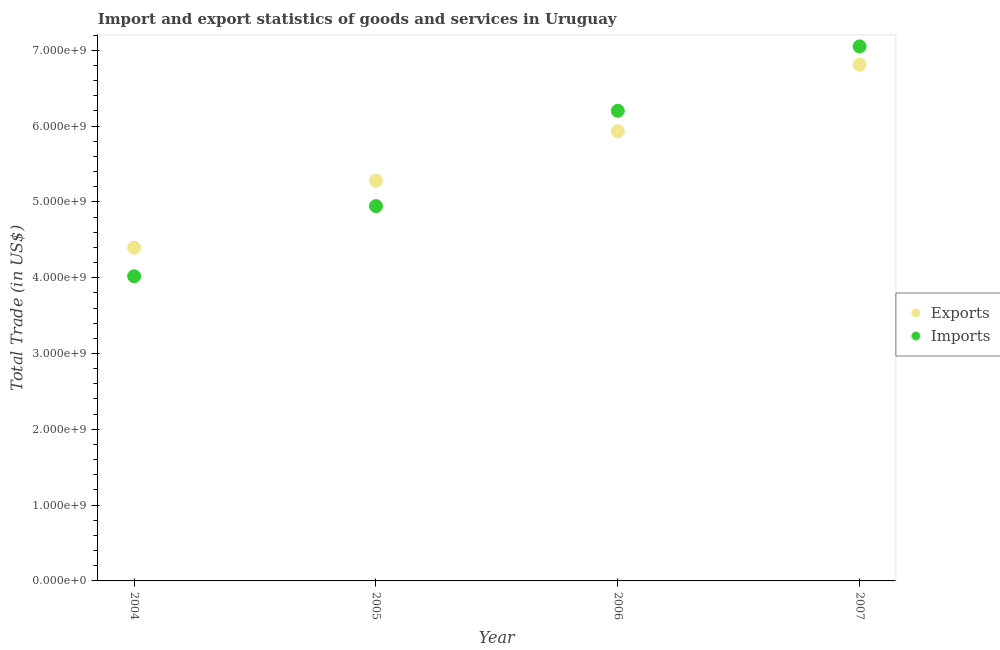How many different coloured dotlines are there?
Provide a succinct answer. 2. Is the number of dotlines equal to the number of legend labels?
Make the answer very short. Yes. What is the imports of goods and services in 2005?
Keep it short and to the point. 4.94e+09. Across all years, what is the maximum export of goods and services?
Give a very brief answer. 6.81e+09. Across all years, what is the minimum imports of goods and services?
Your answer should be compact. 4.02e+09. In which year was the imports of goods and services maximum?
Your answer should be compact. 2007. In which year was the imports of goods and services minimum?
Your answer should be very brief. 2004. What is the total imports of goods and services in the graph?
Give a very brief answer. 2.22e+1. What is the difference between the export of goods and services in 2004 and that in 2007?
Offer a terse response. -2.42e+09. What is the difference between the imports of goods and services in 2007 and the export of goods and services in 2005?
Give a very brief answer. 1.77e+09. What is the average imports of goods and services per year?
Provide a succinct answer. 5.55e+09. In the year 2005, what is the difference between the imports of goods and services and export of goods and services?
Your answer should be compact. -3.35e+08. In how many years, is the export of goods and services greater than 800000000 US$?
Offer a terse response. 4. What is the ratio of the export of goods and services in 2004 to that in 2006?
Your answer should be very brief. 0.74. Is the difference between the export of goods and services in 2006 and 2007 greater than the difference between the imports of goods and services in 2006 and 2007?
Ensure brevity in your answer.  No. What is the difference between the highest and the second highest export of goods and services?
Your response must be concise. 8.78e+08. What is the difference between the highest and the lowest imports of goods and services?
Your response must be concise. 3.03e+09. Does the imports of goods and services monotonically increase over the years?
Give a very brief answer. Yes. How many dotlines are there?
Your answer should be compact. 2. How many years are there in the graph?
Ensure brevity in your answer.  4. Are the values on the major ticks of Y-axis written in scientific E-notation?
Keep it short and to the point. Yes. Does the graph contain any zero values?
Offer a very short reply. No. Does the graph contain grids?
Your answer should be very brief. No. Where does the legend appear in the graph?
Make the answer very short. Center right. How many legend labels are there?
Provide a short and direct response. 2. What is the title of the graph?
Give a very brief answer. Import and export statistics of goods and services in Uruguay. Does "By country of asylum" appear as one of the legend labels in the graph?
Give a very brief answer. No. What is the label or title of the Y-axis?
Ensure brevity in your answer.  Total Trade (in US$). What is the Total Trade (in US$) in Exports in 2004?
Your answer should be very brief. 4.39e+09. What is the Total Trade (in US$) in Imports in 2004?
Provide a short and direct response. 4.02e+09. What is the Total Trade (in US$) of Exports in 2005?
Provide a succinct answer. 5.28e+09. What is the Total Trade (in US$) of Imports in 2005?
Your response must be concise. 4.94e+09. What is the Total Trade (in US$) in Exports in 2006?
Give a very brief answer. 5.93e+09. What is the Total Trade (in US$) of Imports in 2006?
Your response must be concise. 6.20e+09. What is the Total Trade (in US$) in Exports in 2007?
Your answer should be very brief. 6.81e+09. What is the Total Trade (in US$) in Imports in 2007?
Offer a very short reply. 7.05e+09. Across all years, what is the maximum Total Trade (in US$) of Exports?
Offer a terse response. 6.81e+09. Across all years, what is the maximum Total Trade (in US$) in Imports?
Provide a short and direct response. 7.05e+09. Across all years, what is the minimum Total Trade (in US$) of Exports?
Offer a very short reply. 4.39e+09. Across all years, what is the minimum Total Trade (in US$) in Imports?
Make the answer very short. 4.02e+09. What is the total Total Trade (in US$) in Exports in the graph?
Provide a short and direct response. 2.24e+1. What is the total Total Trade (in US$) in Imports in the graph?
Offer a very short reply. 2.22e+1. What is the difference between the Total Trade (in US$) of Exports in 2004 and that in 2005?
Offer a very short reply. -8.84e+08. What is the difference between the Total Trade (in US$) of Imports in 2004 and that in 2005?
Keep it short and to the point. -9.25e+08. What is the difference between the Total Trade (in US$) of Exports in 2004 and that in 2006?
Your response must be concise. -1.54e+09. What is the difference between the Total Trade (in US$) of Imports in 2004 and that in 2006?
Your response must be concise. -2.18e+09. What is the difference between the Total Trade (in US$) in Exports in 2004 and that in 2007?
Keep it short and to the point. -2.42e+09. What is the difference between the Total Trade (in US$) in Imports in 2004 and that in 2007?
Make the answer very short. -3.03e+09. What is the difference between the Total Trade (in US$) of Exports in 2005 and that in 2006?
Provide a short and direct response. -6.53e+08. What is the difference between the Total Trade (in US$) of Imports in 2005 and that in 2006?
Offer a very short reply. -1.26e+09. What is the difference between the Total Trade (in US$) in Exports in 2005 and that in 2007?
Your answer should be very brief. -1.53e+09. What is the difference between the Total Trade (in US$) in Imports in 2005 and that in 2007?
Give a very brief answer. -2.11e+09. What is the difference between the Total Trade (in US$) in Exports in 2006 and that in 2007?
Make the answer very short. -8.78e+08. What is the difference between the Total Trade (in US$) in Imports in 2006 and that in 2007?
Your answer should be very brief. -8.50e+08. What is the difference between the Total Trade (in US$) of Exports in 2004 and the Total Trade (in US$) of Imports in 2005?
Ensure brevity in your answer.  -5.49e+08. What is the difference between the Total Trade (in US$) of Exports in 2004 and the Total Trade (in US$) of Imports in 2006?
Offer a terse response. -1.81e+09. What is the difference between the Total Trade (in US$) of Exports in 2004 and the Total Trade (in US$) of Imports in 2007?
Keep it short and to the point. -2.66e+09. What is the difference between the Total Trade (in US$) of Exports in 2005 and the Total Trade (in US$) of Imports in 2006?
Keep it short and to the point. -9.23e+08. What is the difference between the Total Trade (in US$) in Exports in 2005 and the Total Trade (in US$) in Imports in 2007?
Provide a succinct answer. -1.77e+09. What is the difference between the Total Trade (in US$) of Exports in 2006 and the Total Trade (in US$) of Imports in 2007?
Make the answer very short. -1.12e+09. What is the average Total Trade (in US$) in Exports per year?
Keep it short and to the point. 5.60e+09. What is the average Total Trade (in US$) of Imports per year?
Ensure brevity in your answer.  5.55e+09. In the year 2004, what is the difference between the Total Trade (in US$) in Exports and Total Trade (in US$) in Imports?
Provide a short and direct response. 3.76e+08. In the year 2005, what is the difference between the Total Trade (in US$) in Exports and Total Trade (in US$) in Imports?
Give a very brief answer. 3.35e+08. In the year 2006, what is the difference between the Total Trade (in US$) of Exports and Total Trade (in US$) of Imports?
Give a very brief answer. -2.70e+08. In the year 2007, what is the difference between the Total Trade (in US$) of Exports and Total Trade (in US$) of Imports?
Your response must be concise. -2.41e+08. What is the ratio of the Total Trade (in US$) of Exports in 2004 to that in 2005?
Give a very brief answer. 0.83. What is the ratio of the Total Trade (in US$) in Imports in 2004 to that in 2005?
Your response must be concise. 0.81. What is the ratio of the Total Trade (in US$) of Exports in 2004 to that in 2006?
Your answer should be very brief. 0.74. What is the ratio of the Total Trade (in US$) of Imports in 2004 to that in 2006?
Provide a short and direct response. 0.65. What is the ratio of the Total Trade (in US$) of Exports in 2004 to that in 2007?
Provide a short and direct response. 0.65. What is the ratio of the Total Trade (in US$) in Imports in 2004 to that in 2007?
Give a very brief answer. 0.57. What is the ratio of the Total Trade (in US$) in Exports in 2005 to that in 2006?
Provide a short and direct response. 0.89. What is the ratio of the Total Trade (in US$) of Imports in 2005 to that in 2006?
Make the answer very short. 0.8. What is the ratio of the Total Trade (in US$) in Exports in 2005 to that in 2007?
Make the answer very short. 0.78. What is the ratio of the Total Trade (in US$) of Imports in 2005 to that in 2007?
Keep it short and to the point. 0.7. What is the ratio of the Total Trade (in US$) of Exports in 2006 to that in 2007?
Your response must be concise. 0.87. What is the ratio of the Total Trade (in US$) in Imports in 2006 to that in 2007?
Your response must be concise. 0.88. What is the difference between the highest and the second highest Total Trade (in US$) in Exports?
Your answer should be compact. 8.78e+08. What is the difference between the highest and the second highest Total Trade (in US$) of Imports?
Provide a short and direct response. 8.50e+08. What is the difference between the highest and the lowest Total Trade (in US$) in Exports?
Offer a terse response. 2.42e+09. What is the difference between the highest and the lowest Total Trade (in US$) in Imports?
Give a very brief answer. 3.03e+09. 